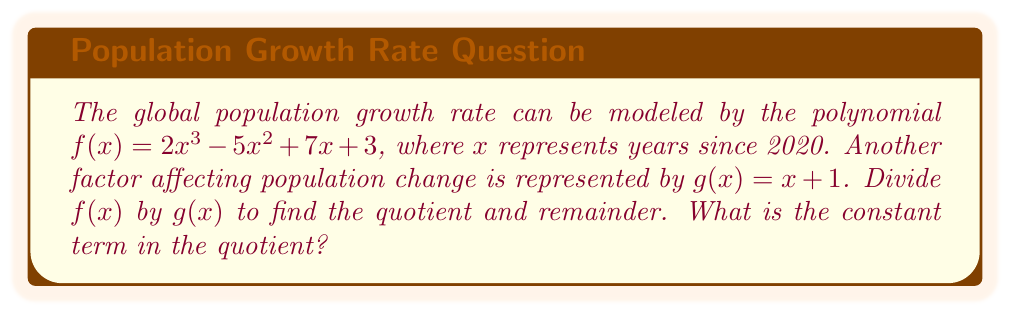What is the answer to this math problem? Let's divide $f(x)$ by $g(x)$ using polynomial long division:

$$\begin{array}{r}
2x^2 - 7x + 12 \\
x + 1 \enclose{longdiv}{2x^3 - 5x^2 + 7x + 3} \\
\underline{2x^3 + 2x^2} \\
-7x^2 + 7x \\
\underline{-7x^2 - 7x} \\
14x + 3 \\
\underline{14x + 14} \\
-11
\end{array}$$

Step 1: Divide $2x^3$ by $x$ to get $2x^2$. Multiply $(x+1)(2x^2) = 2x^3 + 2x^2$ and subtract.

Step 2: Bring down $-5x^2 + 7x$. Now we have $-7x^2 + 7x$.

Step 3: Divide $-7x^2$ by $x$ to get $-7x$. Multiply $(x+1)(-7x) = -7x^2 - 7x$ and subtract.

Step 4: Bring down $3$. Now we have $14x + 3$.

Step 5: Divide $14x$ by $x$ to get $14$. Multiply $(x+1)(14) = 14x + 14$ and subtract.

The final result is:
Quotient: $2x^2 - 7x + 14$
Remainder: $-11$

The constant term in the quotient is 14.
Answer: 14 